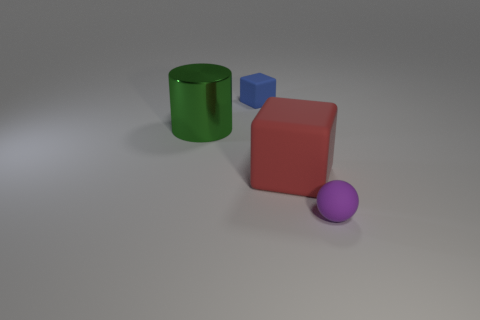Do the thing behind the metallic cylinder and the big metal cylinder have the same size?
Your response must be concise. No. Do the rubber sphere and the cylinder have the same color?
Ensure brevity in your answer.  No. How many objects are both in front of the small blue object and on the right side of the green metallic cylinder?
Give a very brief answer. 2. What number of large green things are in front of the tiny object to the right of the tiny rubber thing that is behind the purple thing?
Provide a short and direct response. 0. What is the shape of the purple rubber thing?
Offer a very short reply. Sphere. What number of big purple cubes have the same material as the ball?
Offer a very short reply. 0. There is a block that is made of the same material as the large red thing; what color is it?
Give a very brief answer. Blue. Does the red thing have the same size as the rubber block that is behind the green cylinder?
Keep it short and to the point. No. What material is the cube that is on the right side of the small matte object that is left of the small object that is in front of the metal cylinder?
Provide a succinct answer. Rubber. How many objects are tiny blue rubber cubes or green cylinders?
Give a very brief answer. 2. 